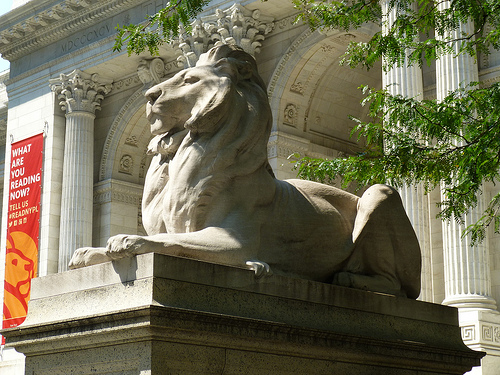<image>
Is the lion to the left of the flag? No. The lion is not to the left of the flag. From this viewpoint, they have a different horizontal relationship. 